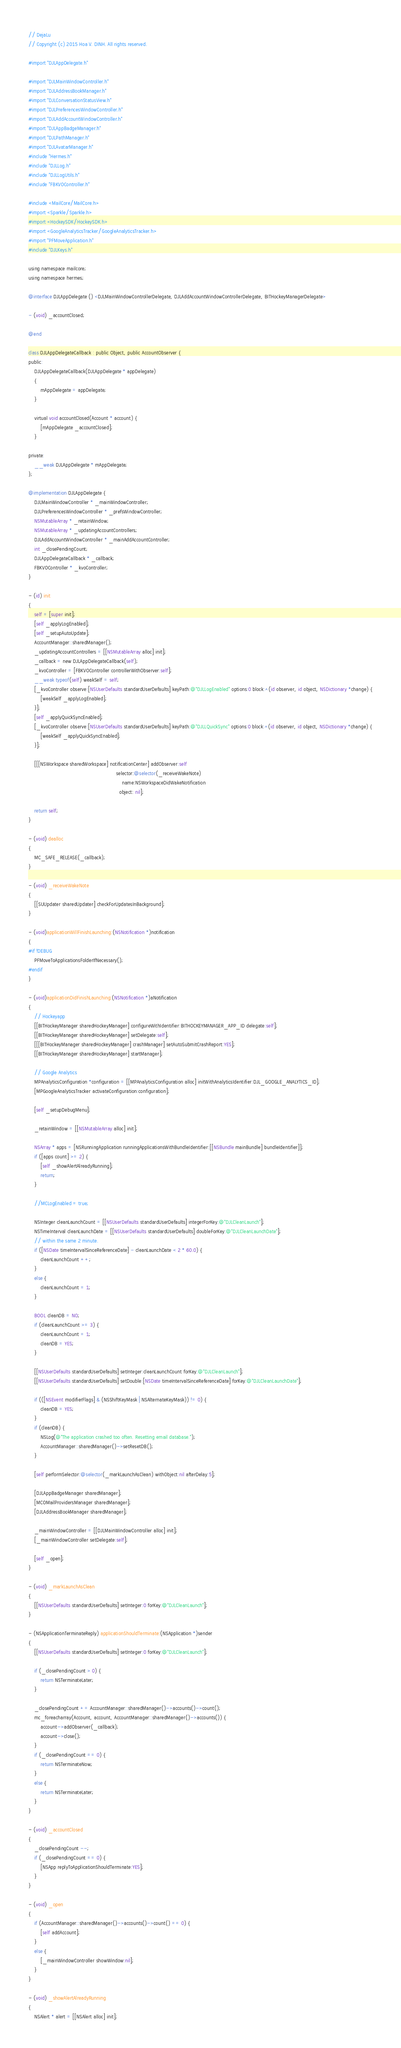Convert code to text. <code><loc_0><loc_0><loc_500><loc_500><_ObjectiveC_>// DejaLu
// Copyright (c) 2015 Hoa V. DINH. All rights reserved.

#import "DJLAppDelegate.h"

#import "DJLMainWindowController.h"
#import "DJLAddressBookManager.h"
#import "DJLConversationStatusView.h"
#import "DJLPreferencesWindowController.h"
#import "DJLAddAccountWindowController.h"
#import "DJLAppBadgeManager.h"
#import "DJLPathManager.h"
#import "DJLAvatarManager.h"
#include "Hermes.h"
#include "DJLLog.h"
#include "DJLLogUtils.h"
#include "FBKVOController.h"

#include <MailCore/MailCore.h>
#import <Sparkle/Sparkle.h>
#import <HockeySDK/HockeySDK.h>
#import <GoogleAnalyticsTracker/GoogleAnalyticsTracker.h>
#import "PFMoveApplication.h"
#include "DJLKeys.h"

using namespace mailcore;
using namespace hermes;

@interface DJLAppDelegate () <DJLMainWindowControllerDelegate, DJLAddAccountWindowControllerDelegate, BITHockeyManagerDelegate>

- (void) _accountClosed;

@end

class DJLAppDelegateCallback : public Object, public AccountObserver {
public:
    DJLAppDelegateCallback(DJLAppDelegate * appDelegate)
    {
        mAppDelegate = appDelegate;
    }

    virtual void accountClosed(Account * account) {
        [mAppDelegate _accountClosed];
    }

private:
    __weak DJLAppDelegate * mAppDelegate;
};

@implementation DJLAppDelegate {
    DJLMainWindowController * _mainWindowController;
    DJLPreferencesWindowController * _prefsWindowController;
    NSMutableArray * _retainWindow;
    NSMutableArray * _updatingAccountControllers;
    DJLAddAccountWindowController * _mainAddAccountController;
    int _closePendingCount;
    DJLAppDelegateCallback * _callback;
    FBKVOController * _kvoController;
}

- (id) init
{
    self = [super init];
    [self _applyLogEnabled];
    [self _setupAutoUpdate];
    AccountManager::sharedManager();
    _updatingAccountControllers = [[NSMutableArray alloc] init];
    _callback = new DJLAppDelegateCallback(self);
    _kvoController = [FBKVOController controllerWithObserver:self];
    __weak typeof(self) weakSelf = self;
    [_kvoController observe:[NSUserDefaults standardUserDefaults] keyPath:@"DJLLogEnabled" options:0 block:^(id observer, id object, NSDictionary *change) {
        [weakSelf _applyLogEnabled];
    }];
    [self _applyQuickSyncEnabled];
    [_kvoController observe:[NSUserDefaults standardUserDefaults] keyPath:@"DJLLQuickSync" options:0 block:^(id observer, id object, NSDictionary *change) {
        [weakSelf _applyQuickSyncEnabled];
    }];

    [[[NSWorkspace sharedWorkspace] notificationCenter] addObserver:self
                                                           selector:@selector(_receiveWakeNote)
                                                               name:NSWorkspaceDidWakeNotification
                                                             object: nil];

    return self;
}

- (void) dealloc
{
    MC_SAFE_RELEASE(_callback);
}

- (void) _receiveWakeNote
{
    [[SUUpdater sharedUpdater] checkForUpdatesInBackground];
}

- (void)applicationWillFinishLaunching:(NSNotification *)notification
{
#if !DEBUG
    PFMoveToApplicationsFolderIfNecessary();
#endif
}

- (void)applicationDidFinishLaunching:(NSNotification *)aNotification
{
    // Hockeyapp
    [[BITHockeyManager sharedHockeyManager] configureWithIdentifier:BITHOCKEYMANAGER_APP_ID delegate:self];
    [[BITHockeyManager sharedHockeyManager] setDelegate:self];
    [[[BITHockeyManager sharedHockeyManager] crashManager] setAutoSubmitCrashReport:YES];
    [[BITHockeyManager sharedHockeyManager] startManager];

    // Google Analytics
    MPAnalyticsConfiguration *configuration = [[MPAnalyticsConfiguration alloc] initWithAnalyticsIdentifier:DJL_GOOGLE_ANALYTICS_ID];
    [MPGoogleAnalyticsTracker activateConfiguration:configuration];

    [self _setupDebugMenu];

    _retainWindow = [[NSMutableArray alloc] init];
    
    NSArray * apps = [NSRunningApplication runningApplicationsWithBundleIdentifier:[[NSBundle mainBundle] bundleIdentifier]];
    if ([apps count] >= 2) {
        [self _showAlertAlreadyRunning];
        return;
    }

    //MCLogEnabled = true;

    NSInteger cleanLaunchCount = [[NSUserDefaults standardUserDefaults] integerForKey:@"DJLCleanLaunch"];
    NSTimeInterval cleanLaunchDate = [[NSUserDefaults standardUserDefaults] doubleForKey:@"DJLCleanLaunchDate"];
    // within the same 2 minute.
    if ([NSDate timeIntervalSinceReferenceDate] - cleanLaunchDate < 2 * 60.0) {
        cleanLaunchCount ++;
    }
    else {
        cleanLaunchCount = 1;
    }

    BOOL cleanDB = NO;
    if (cleanLaunchCount >= 3) {
        cleanLaunchCount = 1;
        cleanDB = YES;
    }

    [[NSUserDefaults standardUserDefaults] setInteger:cleanLaunchCount forKey:@"DJLCleanLaunch"];
    [[NSUserDefaults standardUserDefaults] setDouble:[NSDate timeIntervalSinceReferenceDate] forKey:@"DJLCleanLaunchDate"];

    if (([NSEvent modifierFlags] & (NSShiftKeyMask | NSAlternateKeyMask)) != 0) {
        cleanDB = YES;
    }
    if (cleanDB) {
        NSLog(@"The application crashed too often. Resetting email database.");
        AccountManager::sharedManager()->setResetDB();
    }

    [self performSelector:@selector(_markLaunchAsClean) withObject:nil afterDelay:5];

    [DJLAppBadgeManager sharedManager];
    [MCOMailProvidersManager sharedManager];
    [DJLAddressBookManager sharedManager];

    _mainWindowController = [[DJLMainWindowController alloc] init];
    [_mainWindowController setDelegate:self];

    [self _open];
}

- (void) _markLaunchAsClean
{
    [[NSUserDefaults standardUserDefaults] setInteger:0 forKey:@"DJLCleanLaunch"];
}

- (NSApplicationTerminateReply) applicationShouldTerminate:(NSApplication *)sender
{
    [[NSUserDefaults standardUserDefaults] setInteger:0 forKey:@"DJLCleanLaunch"];

    if (_closePendingCount > 0) {
        return NSTerminateLater;
    }

    _closePendingCount += AccountManager::sharedManager()->accounts()->count();
    mc_foreacharray(Account, account, AccountManager::sharedManager()->accounts()) {
        account->addObserver(_callback);
        account->close();
    }
    if (_closePendingCount == 0) {
        return NSTerminateNow;
    }
    else {
        return NSTerminateLater;
    }
}

- (void) _accountClosed
{
    _closePendingCount --;
    if (_closePendingCount == 0) {
        [NSApp replyToApplicationShouldTerminate:YES];
    }
}

- (void) _open
{
    if (AccountManager::sharedManager()->accounts()->count() == 0) {
        [self addAccount];
    }
    else {
        [_mainWindowController showWindow:nil];
    }
}

- (void) _showAlertAlreadyRunning
{
    NSAlert * alert = [[NSAlert alloc] init];</code> 